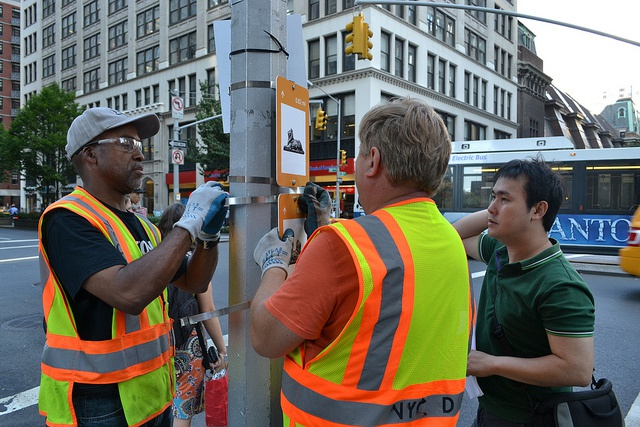Describe the objects in this image and their specific colors. I can see people in lightblue, gray, red, olive, and lightgreen tones, people in lightblue, black, gray, red, and olive tones, people in lightblue, black, gray, and maroon tones, bus in lightblue, black, purple, and blue tones, and handbag in lightblue, black, purple, blue, and navy tones in this image. 